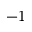<formula> <loc_0><loc_0><loc_500><loc_500>- 1</formula> 